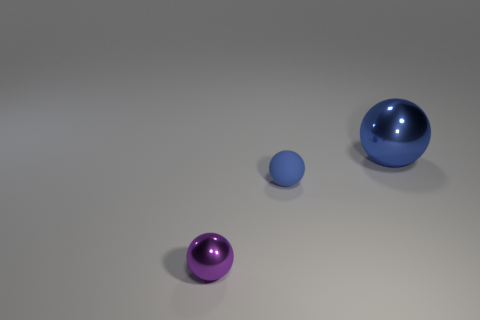What materials do the objects in the image appear to be made of? The objects in the image seem to be made of different materials. The small purple ball appears to be made of a matte substance, possibly plastic or rubber, while the larger blue and purple balls have a reflective surface that suggests they are made of a polished metal or a material with a metallic finish. 